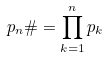Convert formula to latex. <formula><loc_0><loc_0><loc_500><loc_500>p _ { n } \# = \prod _ { k = 1 } ^ { n } p _ { k }</formula> 